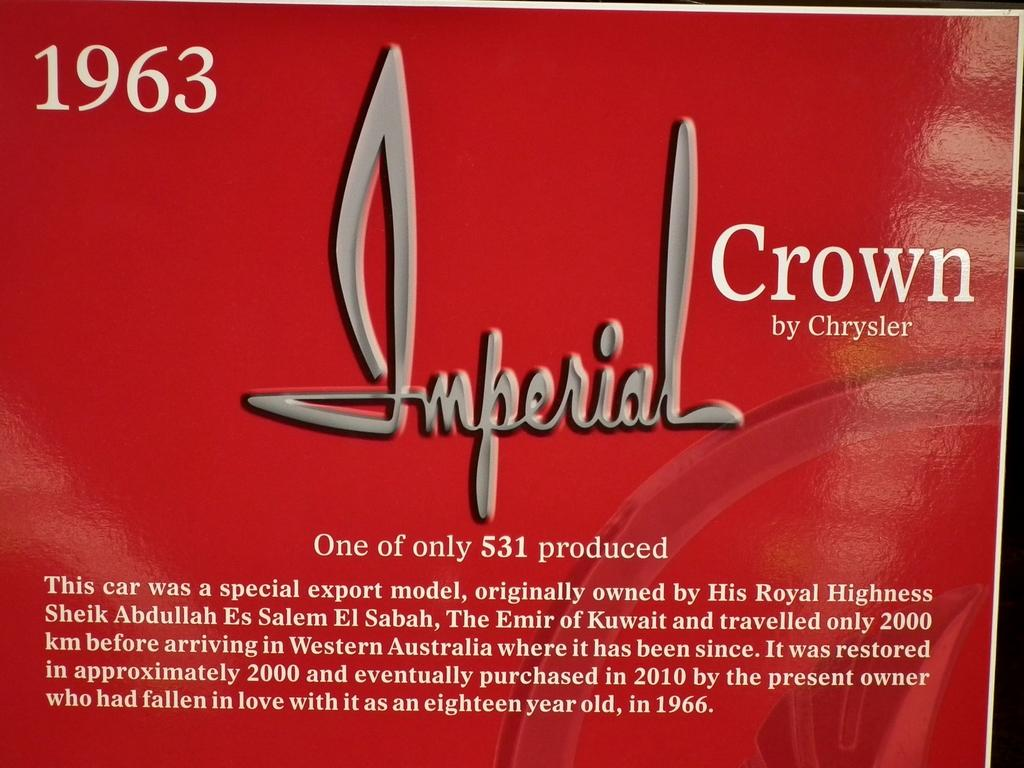<image>
Give a short and clear explanation of the subsequent image. An advertisement for Chrysler's 1963 Imperial Crown car announcing only 531 were produced. 